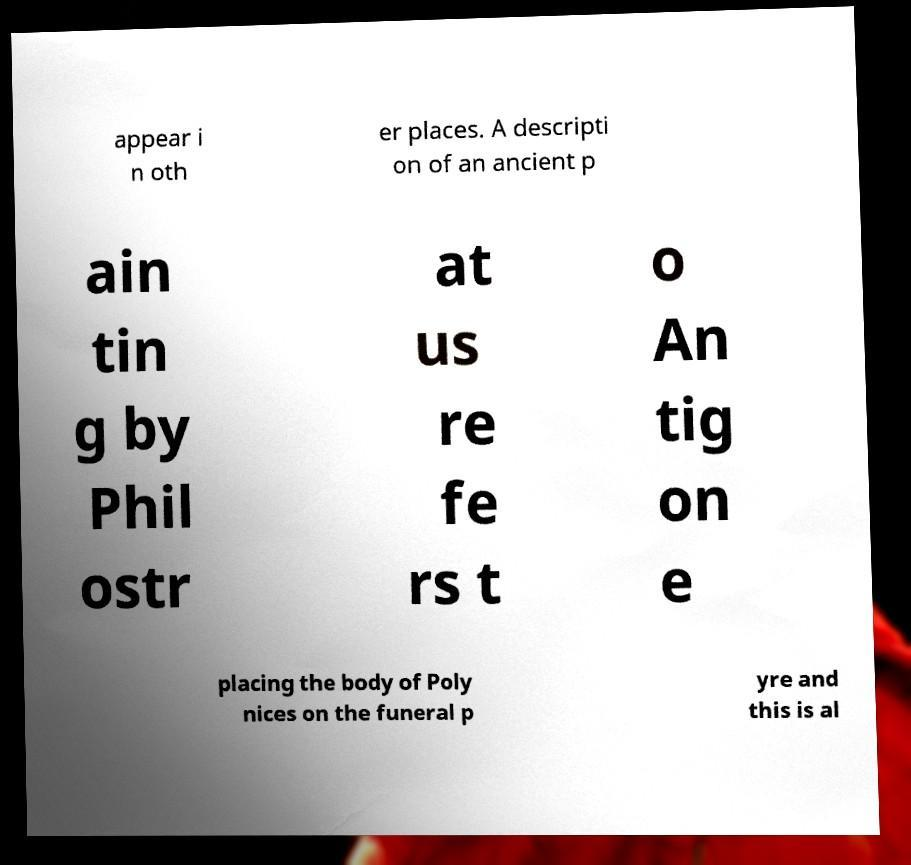What messages or text are displayed in this image? I need them in a readable, typed format. appear i n oth er places. A descripti on of an ancient p ain tin g by Phil ostr at us re fe rs t o An tig on e placing the body of Poly nices on the funeral p yre and this is al 